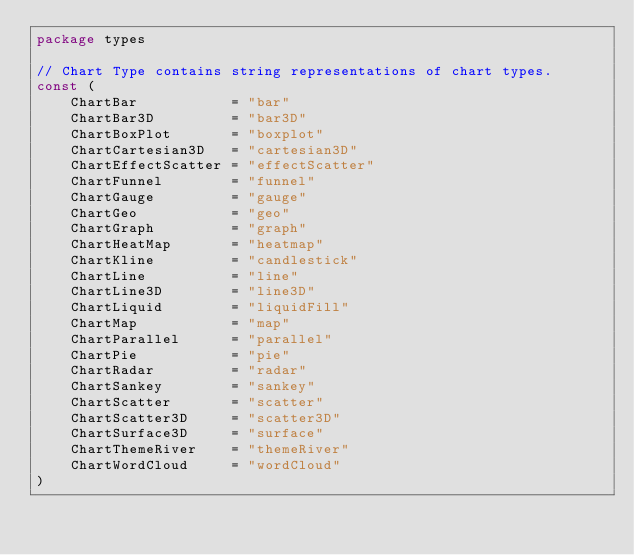<code> <loc_0><loc_0><loc_500><loc_500><_Go_>package types

// Chart Type contains string representations of chart types.
const (
	ChartBar           = "bar"
	ChartBar3D         = "bar3D"
	ChartBoxPlot       = "boxplot"
	ChartCartesian3D   = "cartesian3D"
	ChartEffectScatter = "effectScatter"
	ChartFunnel        = "funnel"
	ChartGauge         = "gauge"
	ChartGeo           = "geo"
	ChartGraph         = "graph"
	ChartHeatMap       = "heatmap"
	ChartKline         = "candlestick"
	ChartLine          = "line"
	ChartLine3D        = "line3D"
	ChartLiquid        = "liquidFill"
	ChartMap           = "map"
	ChartParallel      = "parallel"
	ChartPie           = "pie"
	ChartRadar         = "radar"
	ChartSankey        = "sankey"
	ChartScatter       = "scatter"
	ChartScatter3D     = "scatter3D"
	ChartSurface3D     = "surface"
	ChartThemeRiver    = "themeRiver"
	ChartWordCloud     = "wordCloud"
)
</code> 